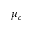Convert formula to latex. <formula><loc_0><loc_0><loc_500><loc_500>\mu _ { c }</formula> 